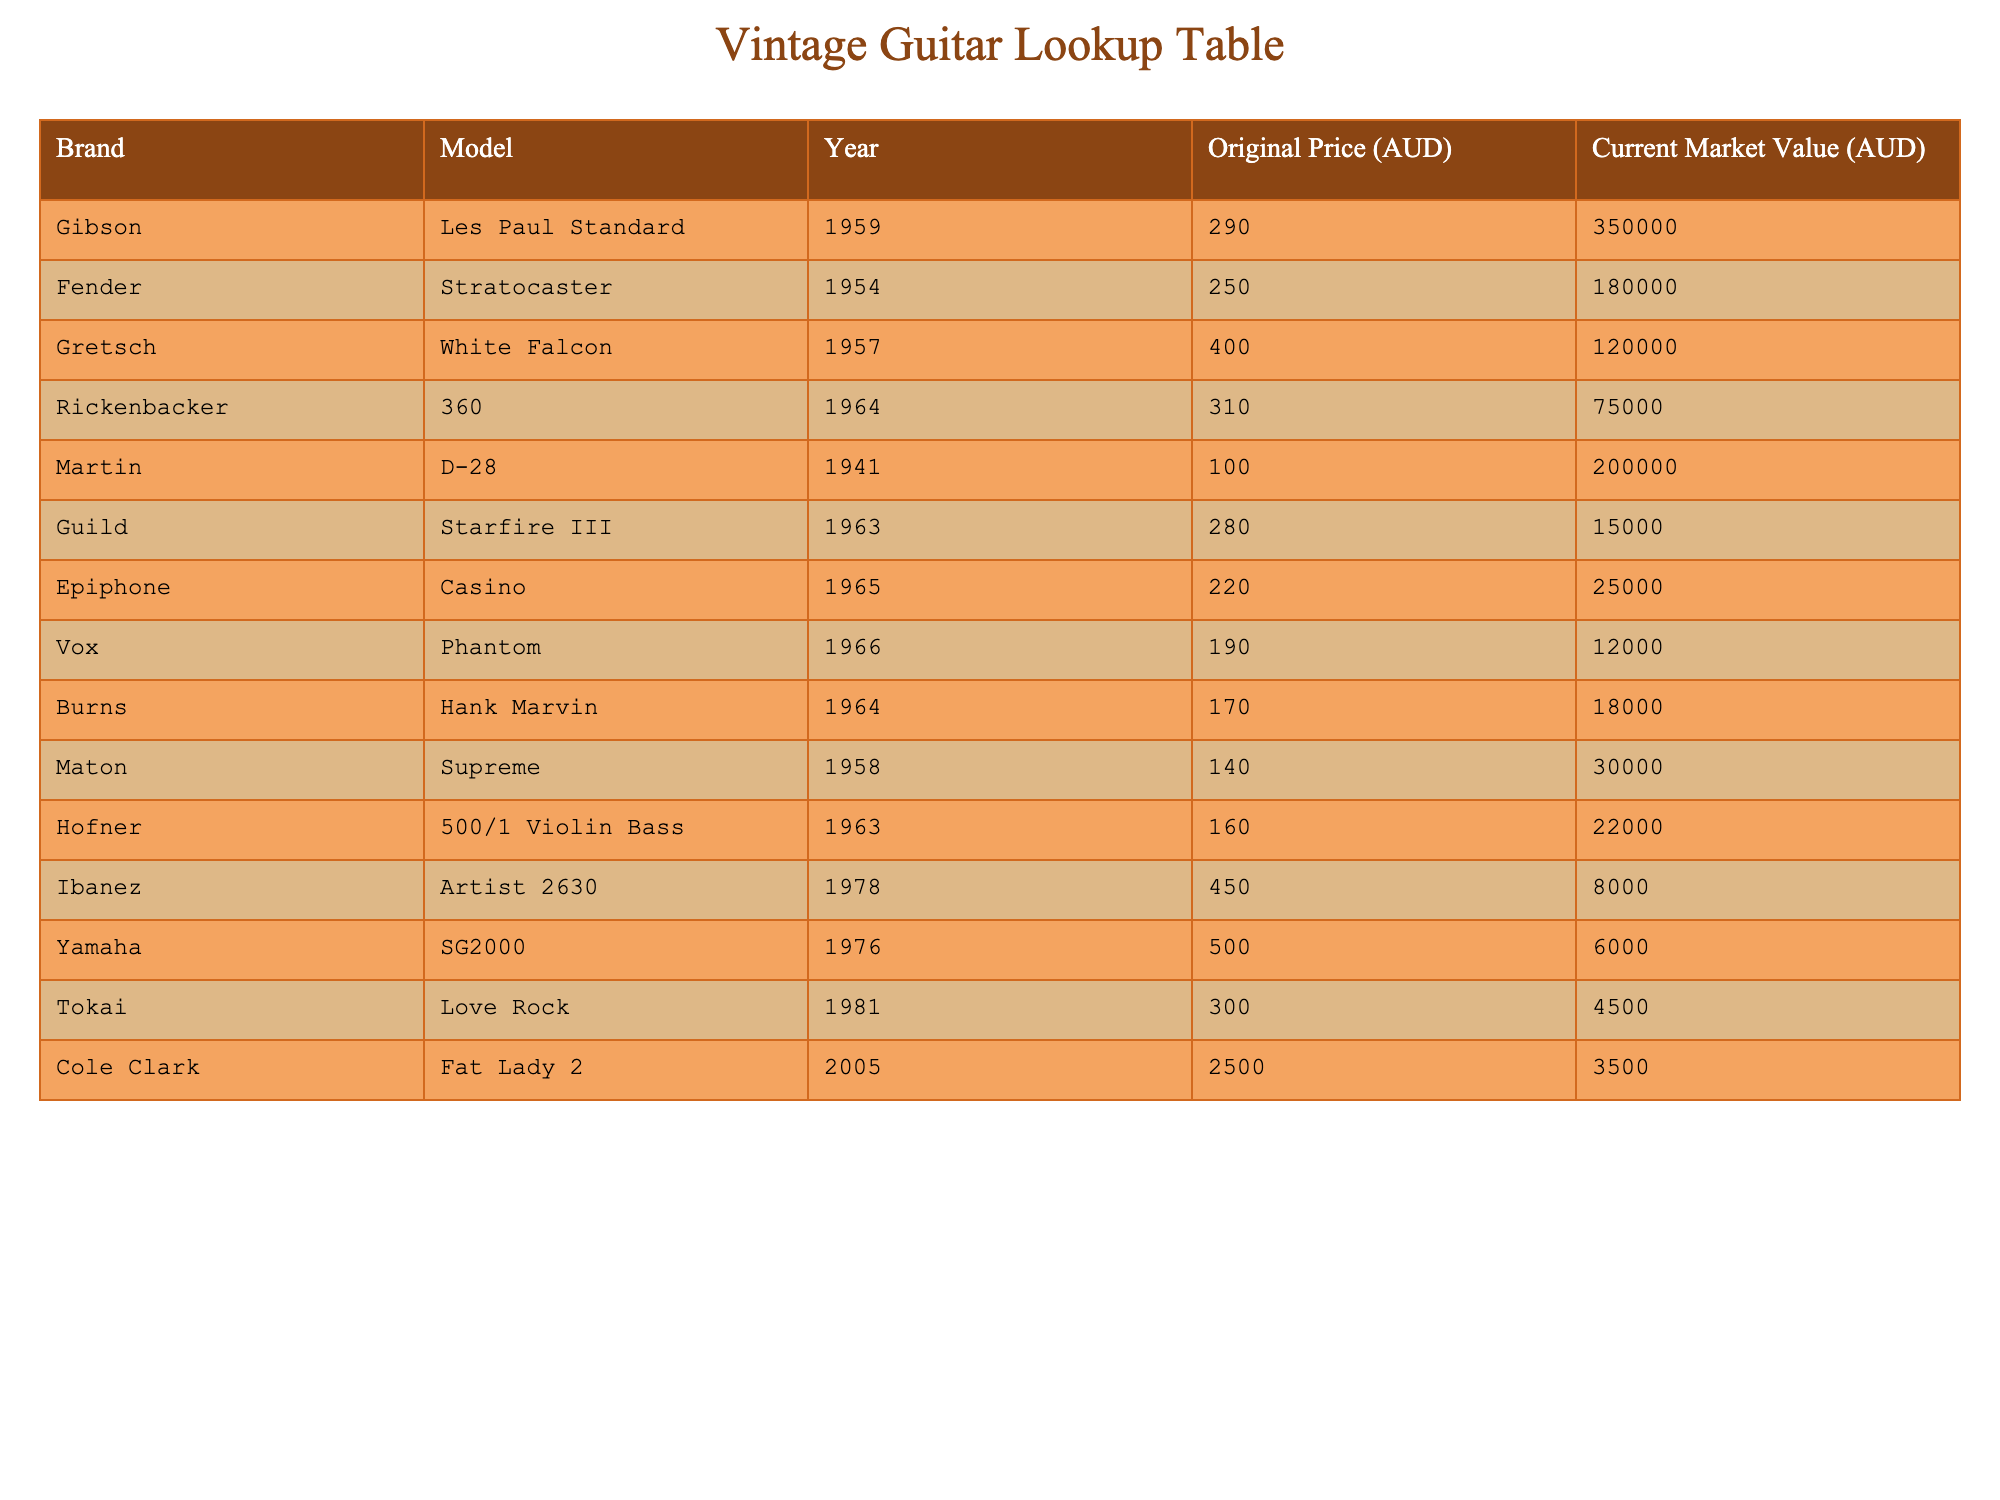What is the current market value of a 1959 Gibson Les Paul Standard? The table lists the current market value under the specified Brand and Model. To find this value, I look for "Gibson" in the Brand column and "Les Paul Standard" in the Model column. The corresponding entry in the Current Market Value column shows 350,000 AUD.
Answer: 350000 AUD Which brand and model has the lowest current market value? To determine this, I need to look through the Current Market Value column and find the minimum value. The lowest market value is 4,500 AUD for the Tokai Love Rock, found in the respective Brand and Model columns.
Answer: Tokai Love Rock What is the difference in current market value between the Fender Stratocaster and Martin D-28? I first check the Current Market Value for Fender Stratocaster which is 180,000 AUD and Martin D-28 which is 200,000 AUD. To find the difference, I subtract 180,000 from 200,000, which gives me 20,000 AUD.
Answer: 20000 AUD Is the original price of the Gretsch White Falcon greater than that of the Rickenbacker 360? I check the Original Price column for Gretsch White Falcon, which is 400 AUD, and Rickenbacker 360, which is 310 AUD. Since 400 AUD is greater than 310 AUD, the statement is true.
Answer: Yes What was the average original price of the guitars listed in the table? To calculate the average, I first sum all the Original Prices: 290 + 250 + 400 + 310 + 100 + 280 + 220 + 190 + 170 + 140 + 450 + 500 + 300 + 2500 = 5100 AUD. There are 14 guitars, so I divide the total by 14, which gives me approximately 364.29 AUD.
Answer: 364.29 AUD How many models from the data were produced before 1970? I look at the Year column to identify models produced before 1970 and count them: Gibson Les Paul Standard (1959), Fender Stratocaster (1954), Gretsch White Falcon (1957), Rickenbacker 360 (1964), Martin D-28 (1941), Guild Starfire III (1963), Epiphone Casino (1965), Vox Phantom (1966), Burns Hank Marvin (1964), Maton Supreme (1958), Hofner 500/1 Violin Bass (1963). This totals to 11 models.
Answer: 11 How much more valuable is the Martin D-28 compared to the Ibanez Artist 2630? Current market values for Martin D-28 is 200,000 AUD and for Ibanez Artist 2630 is 8,000 AUD. To find the difference, I subtract 8,000 from 200,000 which equals 192,000 AUD.
Answer: 192000 AUD Is the current market value of the Yamaha SG2000 higher than that of the Guild Starfire III? I check the Current Market Values: Yamaha SG2000 is 6,000 AUD and Guild Starfire III is 15,000 AUD. Since 6,000 AUD is less than 15,000 AUD, the statement is false.
Answer: No Which vintage guitar brand has the highest original price listed in the table? I review the Original Price column and find that the highest original price is for the Cole Clark Fat Lady 2, which is 2,500 AUD.
Answer: Cole Clark Fat Lady 2 